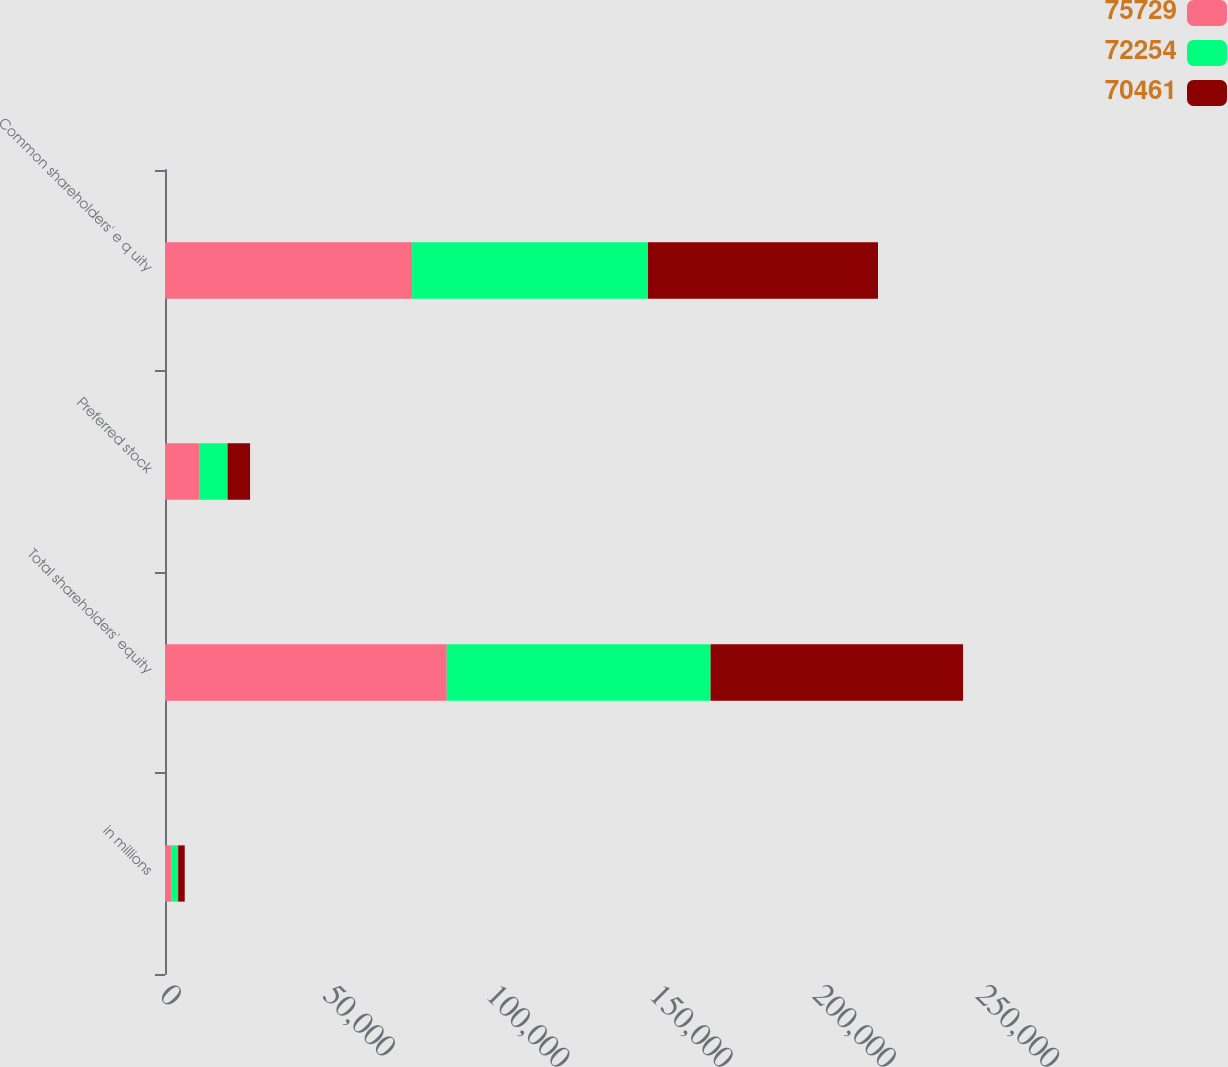<chart> <loc_0><loc_0><loc_500><loc_500><stacked_bar_chart><ecel><fcel>in millions<fcel>Total shareholders' equity<fcel>Preferred stock<fcel>Common shareholders' e q uity<nl><fcel>75729<fcel>2015<fcel>86314<fcel>10585<fcel>75729<nl><fcel>72254<fcel>2014<fcel>80839<fcel>8585<fcel>72254<nl><fcel>70461<fcel>2013<fcel>77353<fcel>6892<fcel>70461<nl></chart> 